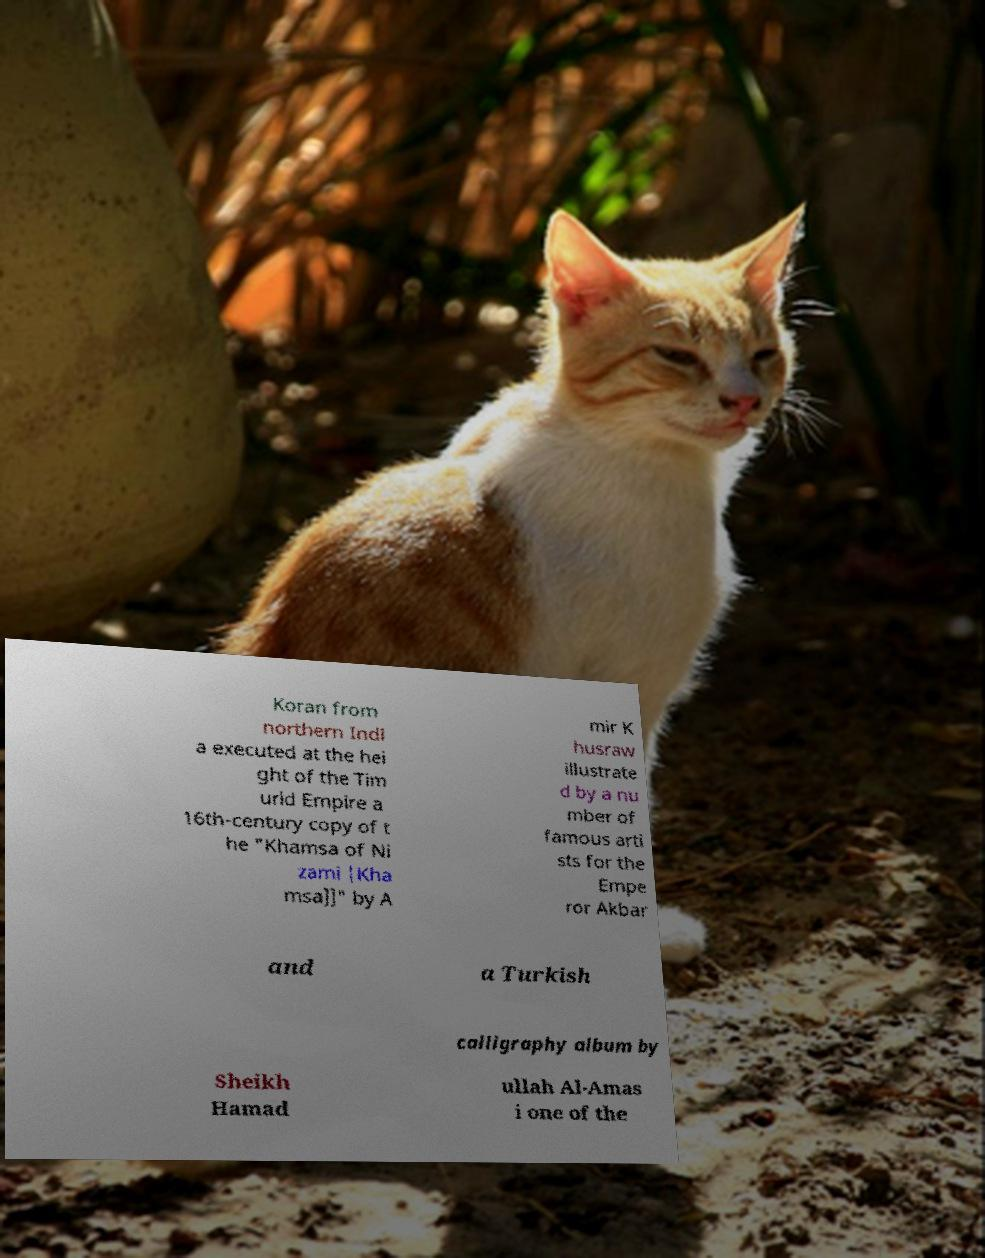Could you extract and type out the text from this image? Koran from northern Indi a executed at the hei ght of the Tim urid Empire a 16th-century copy of t he "Khamsa of Ni zami |Kha msa]]" by A mir K husraw illustrate d by a nu mber of famous arti sts for the Empe ror Akbar and a Turkish calligraphy album by Sheikh Hamad ullah Al-Amas i one of the 